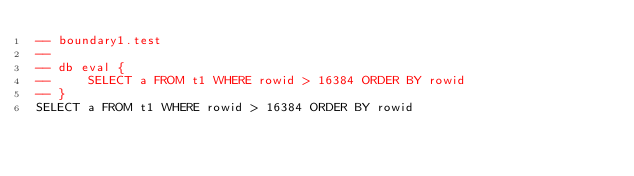<code> <loc_0><loc_0><loc_500><loc_500><_SQL_>-- boundary1.test
-- 
-- db eval {
--     SELECT a FROM t1 WHERE rowid > 16384 ORDER BY rowid
-- }
SELECT a FROM t1 WHERE rowid > 16384 ORDER BY rowid</code> 